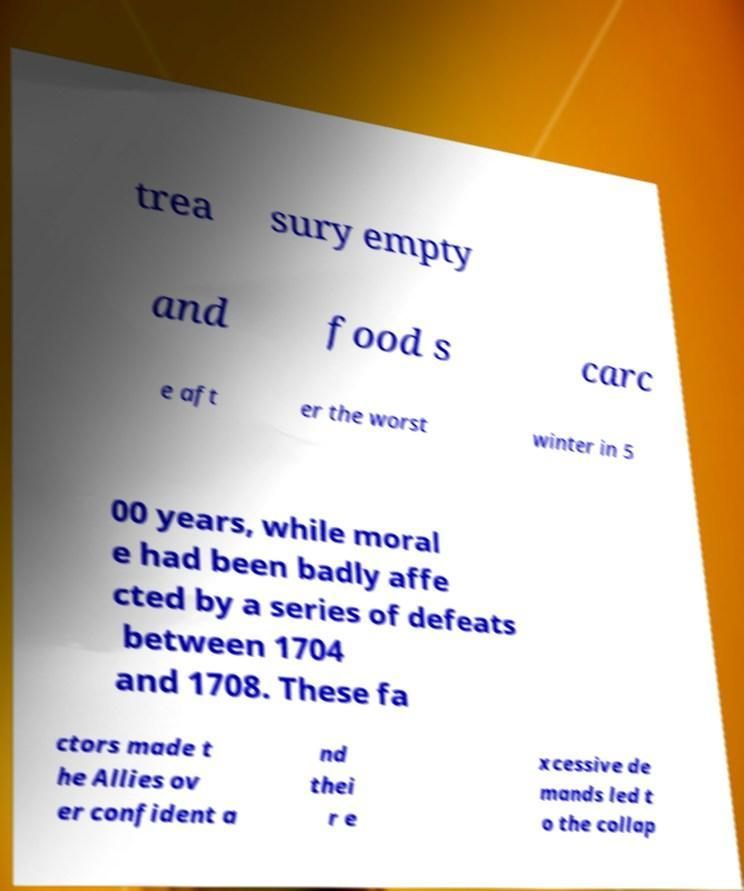What messages or text are displayed in this image? I need them in a readable, typed format. trea sury empty and food s carc e aft er the worst winter in 5 00 years, while moral e had been badly affe cted by a series of defeats between 1704 and 1708. These fa ctors made t he Allies ov er confident a nd thei r e xcessive de mands led t o the collap 